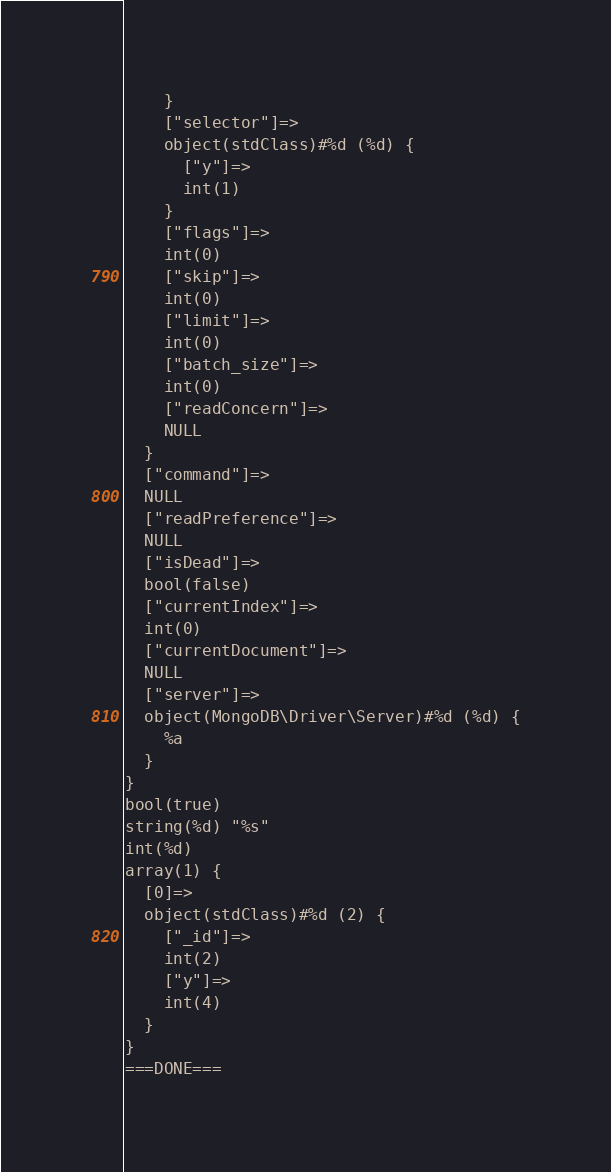<code> <loc_0><loc_0><loc_500><loc_500><_PHP_>    }
    ["selector"]=>
    object(stdClass)#%d (%d) {
      ["y"]=>
      int(1)
    }
    ["flags"]=>
    int(0)
    ["skip"]=>
    int(0)
    ["limit"]=>
    int(0)
    ["batch_size"]=>
    int(0)
    ["readConcern"]=>
    NULL
  }
  ["command"]=>
  NULL
  ["readPreference"]=>
  NULL
  ["isDead"]=>
  bool(false)
  ["currentIndex"]=>
  int(0)
  ["currentDocument"]=>
  NULL
  ["server"]=>
  object(MongoDB\Driver\Server)#%d (%d) {
    %a
  }
}
bool(true)
string(%d) "%s"
int(%d)
array(1) {
  [0]=>
  object(stdClass)#%d (2) {
    ["_id"]=>
    int(2)
    ["y"]=>
    int(4)
  }
}
===DONE===
</code> 